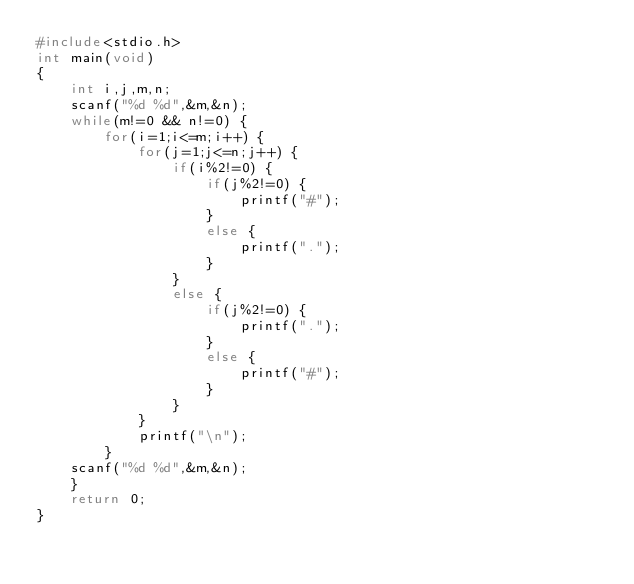<code> <loc_0><loc_0><loc_500><loc_500><_C_>#include<stdio.h>
int main(void)
{
	int i,j,m,n;
	scanf("%d %d",&m,&n);
	while(m!=0 && n!=0) {
		for(i=1;i<=m;i++) {
			for(j=1;j<=n;j++) {
				if(i%2!=0) {
					if(j%2!=0) {
						printf("#");
					}
					else {
						printf(".");
					}
				}
				else {
					if(j%2!=0) {
						printf(".");
					}
					else {
						printf("#");
					}
				}
			}
			printf("\n");
		}
	scanf("%d %d",&m,&n);
	}
	return 0;
}</code> 